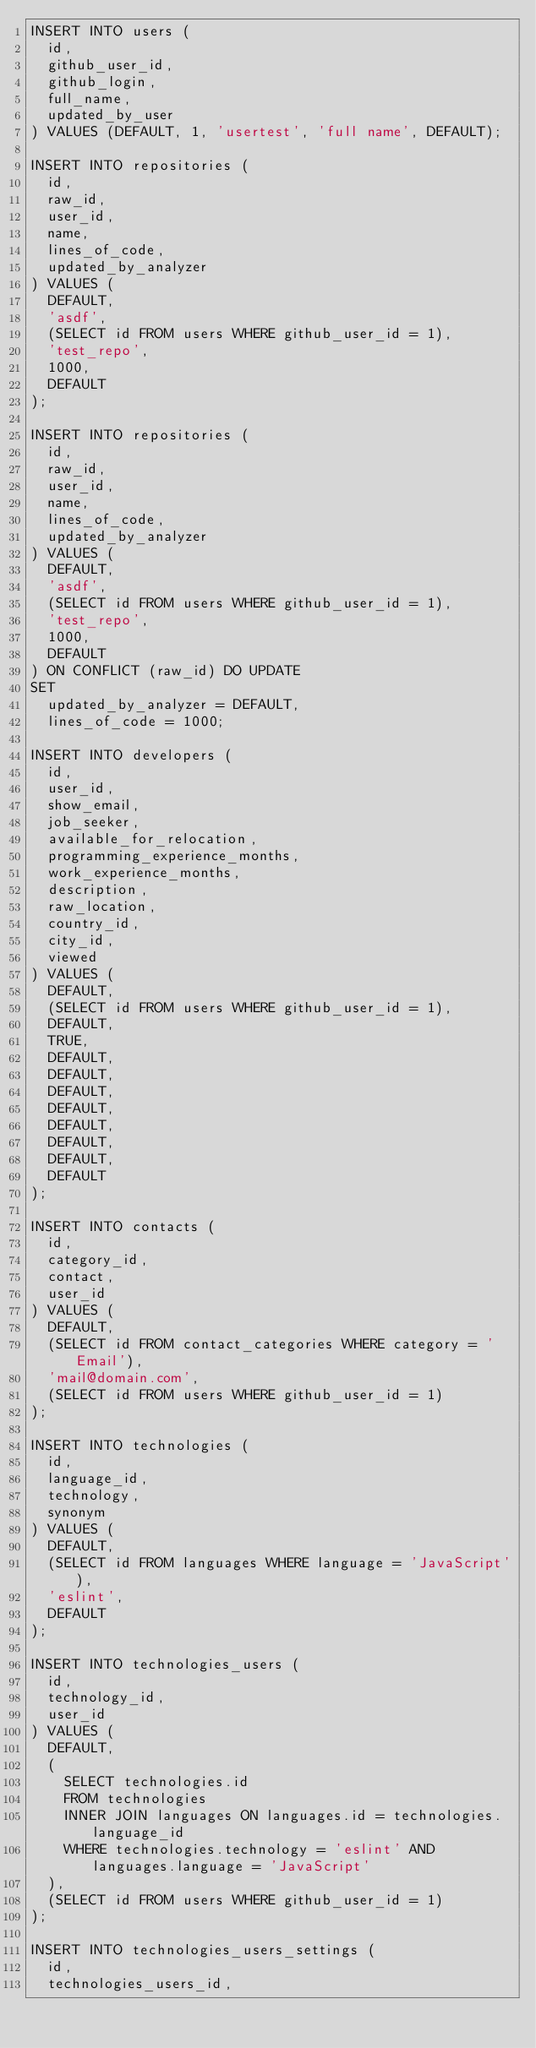Convert code to text. <code><loc_0><loc_0><loc_500><loc_500><_SQL_>INSERT INTO users (
  id,
  github_user_id,
  github_login,
  full_name,
  updated_by_user
) VALUES (DEFAULT, 1, 'usertest', 'full name', DEFAULT);

INSERT INTO repositories (
  id,
  raw_id,
  user_id,
  name,
  lines_of_code,
  updated_by_analyzer
) VALUES (
  DEFAULT,
  'asdf',
  (SELECT id FROM users WHERE github_user_id = 1),
  'test_repo',
  1000,
  DEFAULT
);

INSERT INTO repositories (
  id,
  raw_id,
  user_id,
  name,
  lines_of_code,
  updated_by_analyzer
) VALUES (
  DEFAULT,
  'asdf',
  (SELECT id FROM users WHERE github_user_id = 1),
  'test_repo',
  1000,
  DEFAULT
) ON CONFLICT (raw_id) DO UPDATE
SET
  updated_by_analyzer = DEFAULT,
  lines_of_code = 1000;

INSERT INTO developers (
  id,
  user_id,
  show_email,
  job_seeker,
  available_for_relocation,
  programming_experience_months,
  work_experience_months,
  description,
  raw_location,
  country_id,
  city_id,
  viewed
) VALUES (
  DEFAULT,
  (SELECT id FROM users WHERE github_user_id = 1),
  DEFAULT,
  TRUE,
  DEFAULT,
  DEFAULT,
  DEFAULT,
  DEFAULT,
  DEFAULT,
  DEFAULT,
  DEFAULT,
  DEFAULT
);

INSERT INTO contacts (
  id,
  category_id,
  contact,
  user_id
) VALUES (
  DEFAULT,
  (SELECT id FROM contact_categories WHERE category = 'Email'),
  'mail@domain.com',
  (SELECT id FROM users WHERE github_user_id = 1)
);

INSERT INTO technologies (
  id,
  language_id,
  technology,
  synonym
) VALUES (
  DEFAULT,
  (SELECT id FROM languages WHERE language = 'JavaScript'),
  'eslint',
  DEFAULT
);

INSERT INTO technologies_users (
  id,
  technology_id,
  user_id
) VALUES (
  DEFAULT,
  (
    SELECT technologies.id
    FROM technologies
    INNER JOIN languages ON languages.id = technologies.language_id
    WHERE technologies.technology = 'eslint' AND languages.language = 'JavaScript'
  ),
  (SELECT id FROM users WHERE github_user_id = 1)
);

INSERT INTO technologies_users_settings (
  id,
  technologies_users_id,</code> 